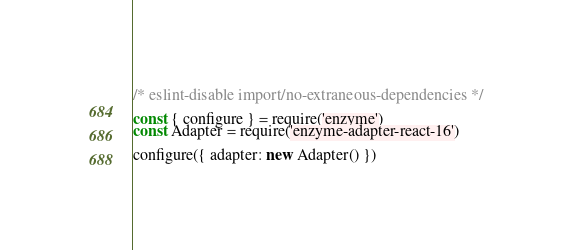Convert code to text. <code><loc_0><loc_0><loc_500><loc_500><_JavaScript_>/* eslint-disable import/no-extraneous-dependencies */

const { configure } = require('enzyme')
const Adapter = require('enzyme-adapter-react-16')

configure({ adapter: new Adapter() })
</code> 